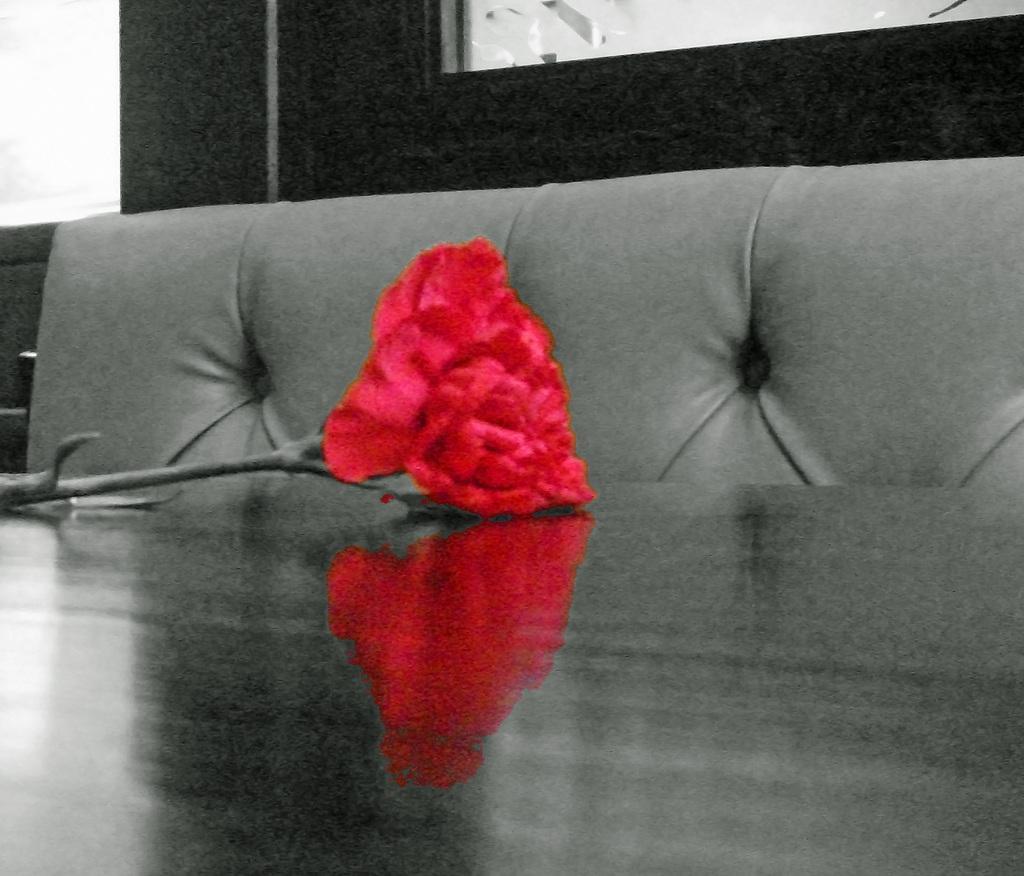In one or two sentences, can you explain what this image depicts? As we can see in the image there is table. On table there is a red color rose and sofa. 